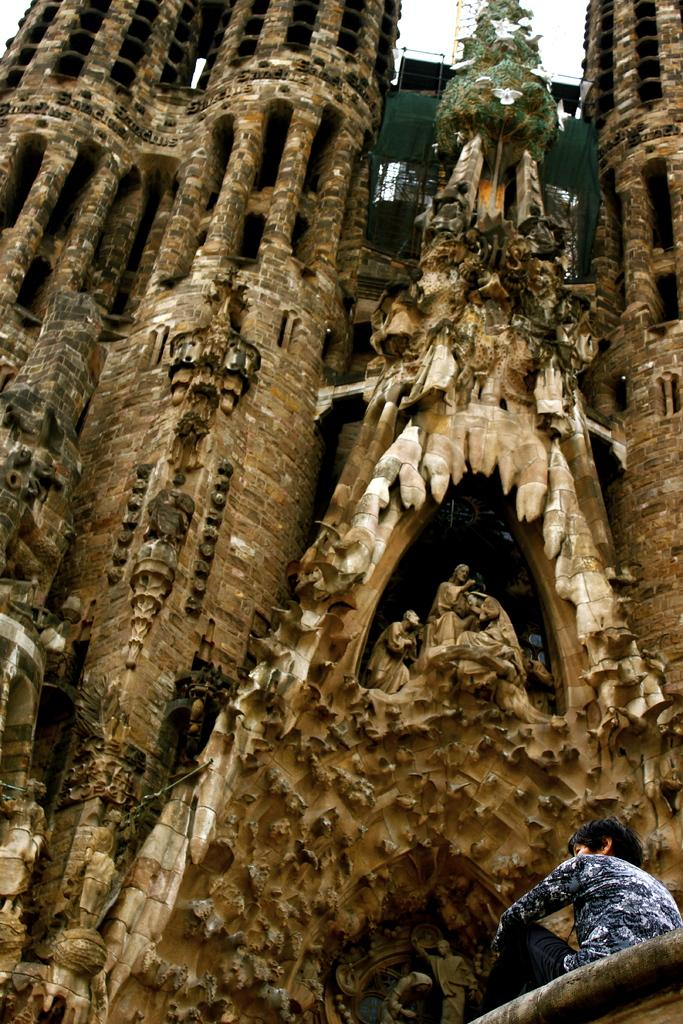What type of building is in the image? There is a cathedral in the image. What can be found on the cathedral? The cathedral has religious sculptures. Can you describe the person in the image? There is a person sitting on a surface in the image. What is the person's opinion on the order of the sculptures in the image? There is no information about the person's opinion on the order of the sculptures in the image. 